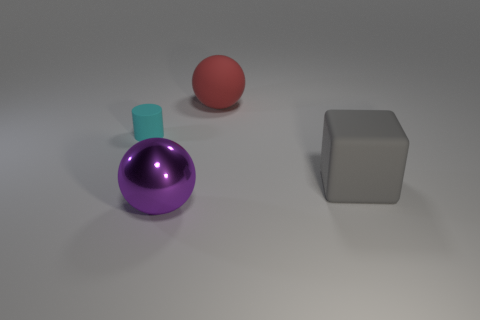Are there any other big things of the same shape as the red thing?
Your response must be concise. Yes. Does the big thing to the left of the large red matte sphere have the same shape as the small thing behind the big gray matte object?
Make the answer very short. No. The matte thing that is both in front of the big matte ball and to the right of the small cyan object has what shape?
Give a very brief answer. Cube. Are there any gray rubber cubes that have the same size as the red rubber sphere?
Ensure brevity in your answer.  Yes. What is the small cylinder made of?
Ensure brevity in your answer.  Rubber. What color is the large object that is behind the tiny matte cylinder?
Offer a terse response. Red. What number of big objects are in front of the small matte thing and to the left of the rubber cube?
Keep it short and to the point. 1. There is a gray object that is the same size as the purple object; what is its shape?
Keep it short and to the point. Cube. How big is the shiny sphere?
Provide a succinct answer. Large. There is a sphere that is behind the large object that is to the left of the big rubber thing that is behind the tiny cyan cylinder; what is its material?
Your answer should be compact. Rubber. 